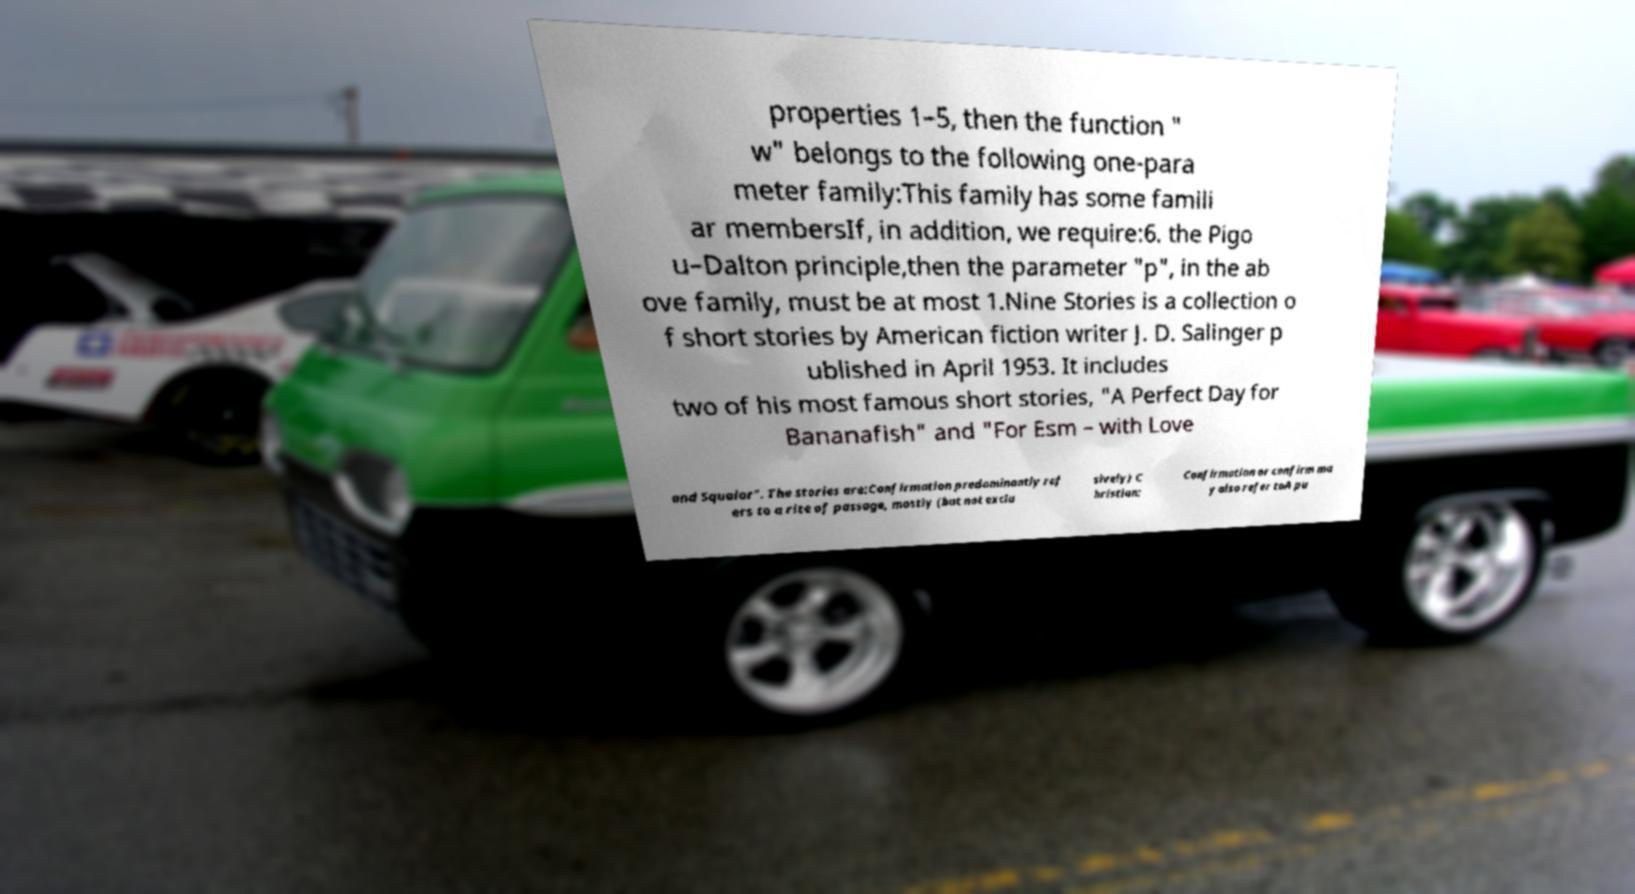Could you assist in decoding the text presented in this image and type it out clearly? properties 1–5, then the function " w" belongs to the following one-para meter family:This family has some famili ar membersIf, in addition, we require:6. the Pigo u–Dalton principle,then the parameter "p", in the ab ove family, must be at most 1.Nine Stories is a collection o f short stories by American fiction writer J. D. Salinger p ublished in April 1953. It includes two of his most famous short stories, "A Perfect Day for Bananafish" and "For Esm – with Love and Squalor". The stories are:Confirmation predominantly ref ers to a rite of passage, mostly (but not exclu sively) C hristian: Confirmation or confirm ma y also refer toA pu 